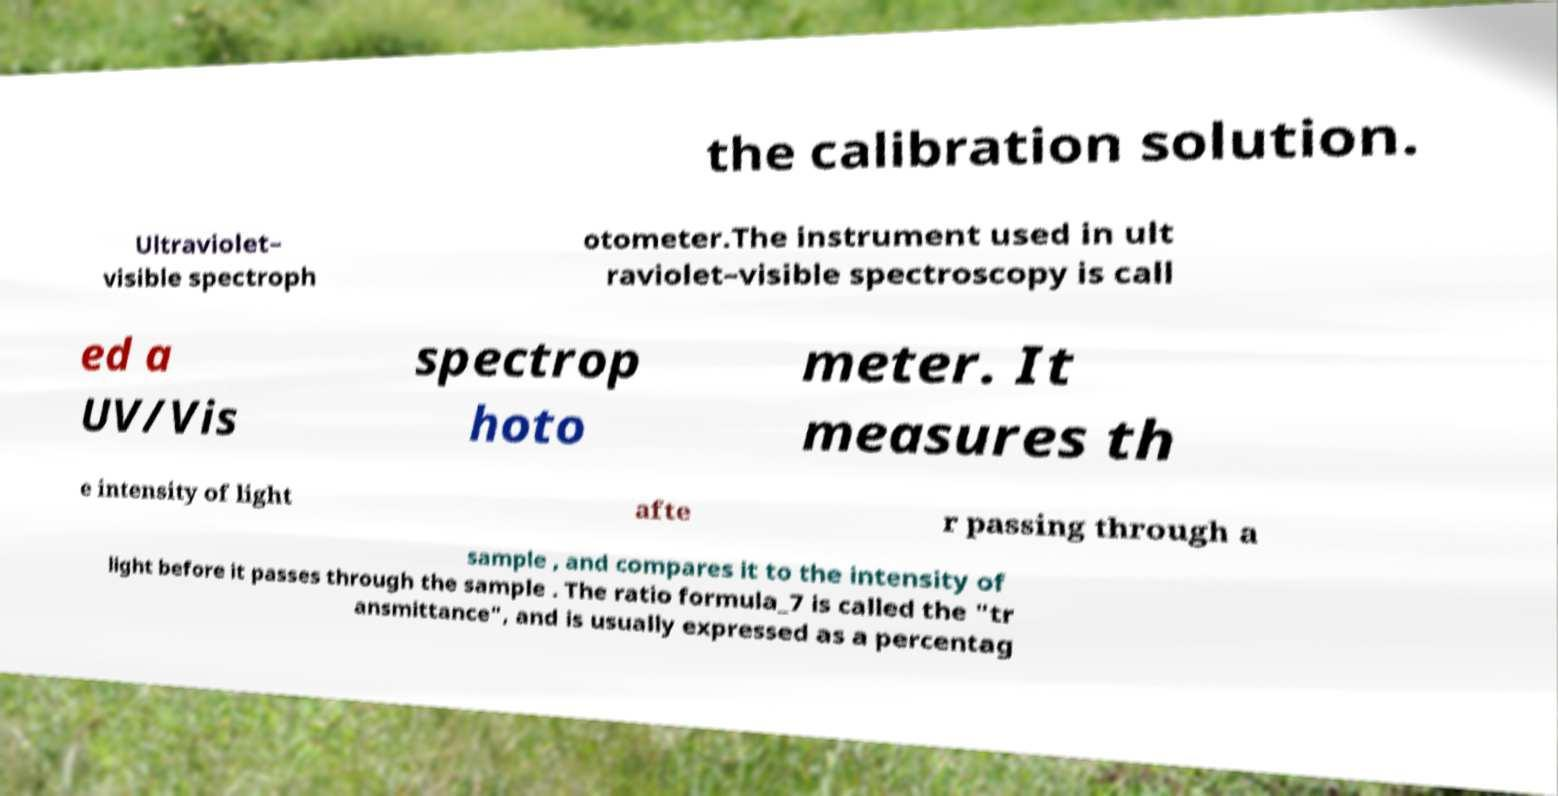For documentation purposes, I need the text within this image transcribed. Could you provide that? the calibration solution. Ultraviolet– visible spectroph otometer.The instrument used in ult raviolet–visible spectroscopy is call ed a UV/Vis spectrop hoto meter. It measures th e intensity of light afte r passing through a sample , and compares it to the intensity of light before it passes through the sample . The ratio formula_7 is called the "tr ansmittance", and is usually expressed as a percentag 